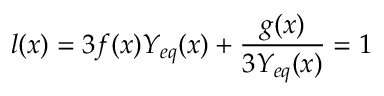Convert formula to latex. <formula><loc_0><loc_0><loc_500><loc_500>l ( x ) = 3 f ( x ) Y _ { e q } ( x ) + \frac { g ( x ) } { 3 Y _ { e q } ( x ) } = 1</formula> 